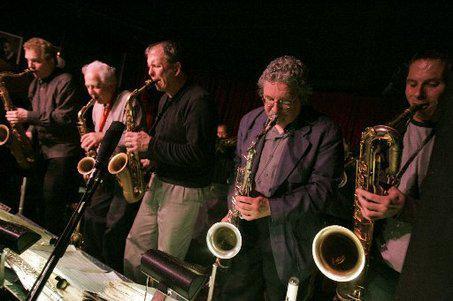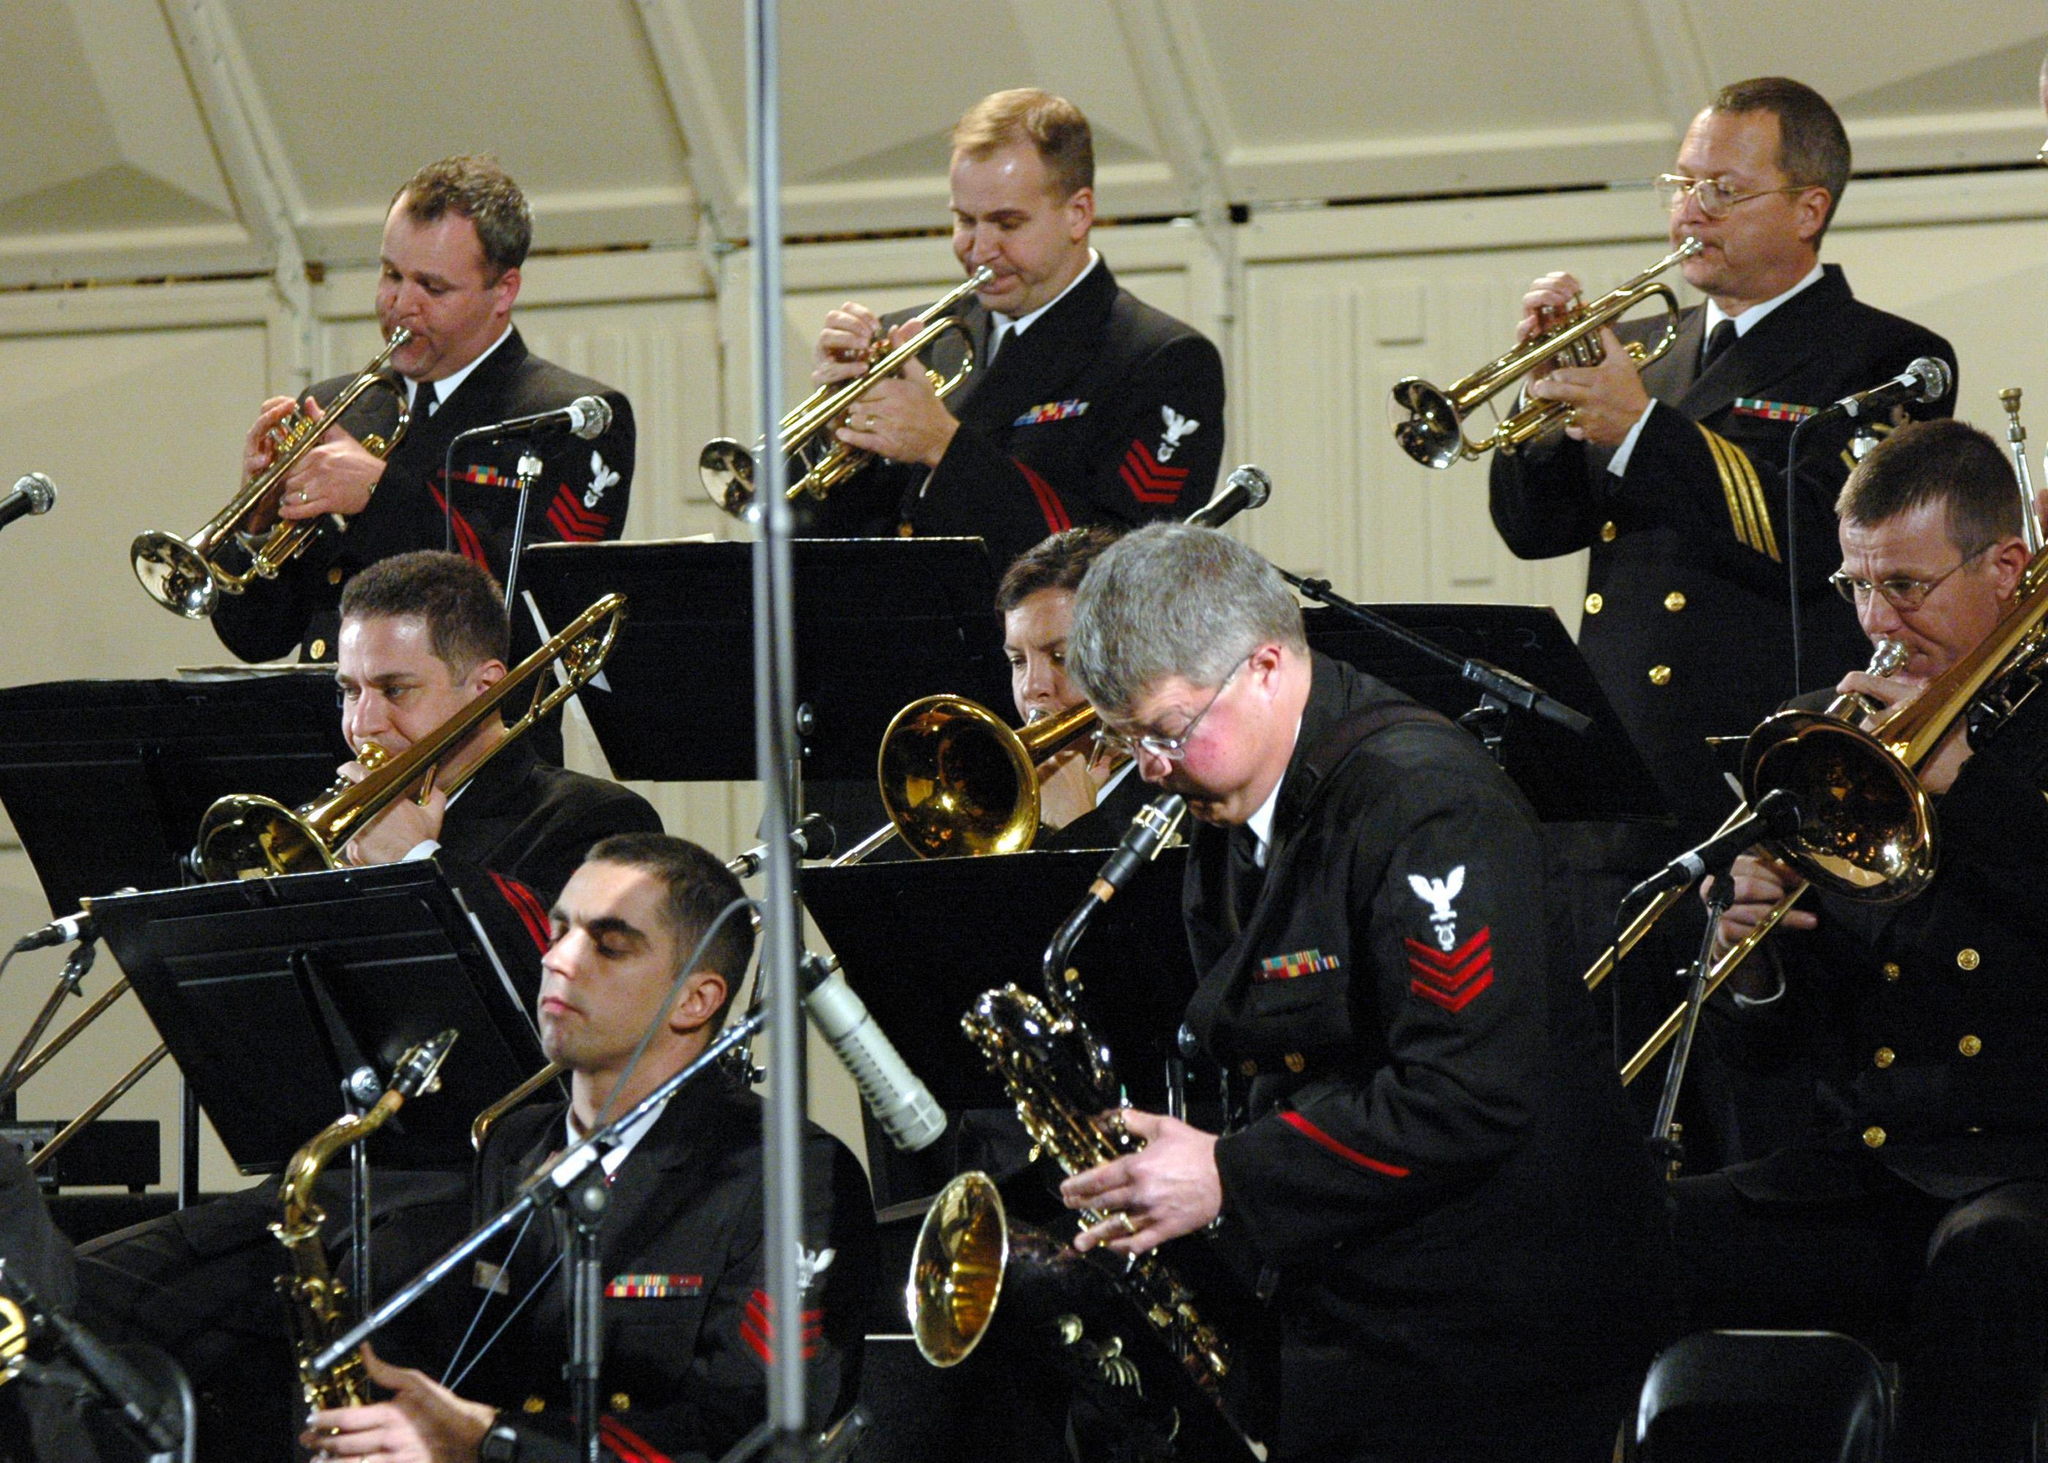The first image is the image on the left, the second image is the image on the right. For the images shown, is this caption "All of the saxophone players are facing rightward and standing in a single row." true? Answer yes or no. No. The first image is the image on the left, the second image is the image on the right. Analyze the images presented: Is the assertion "One of the musicians playing a saxophone depicted in the image on the right is a woman." valid? Answer yes or no. No. 